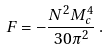Convert formula to latex. <formula><loc_0><loc_0><loc_500><loc_500>F = - \frac { N ^ { 2 } M _ { c } ^ { 4 } } { 3 0 \pi ^ { 2 } } \, .</formula> 